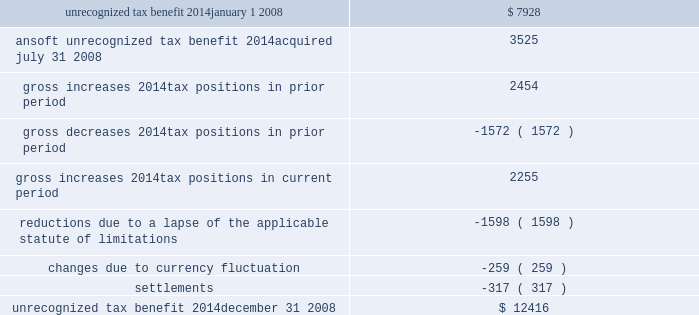The following is a reconciliation of the total amounts of unrecognized tax benefits for the year : ( in thousands ) .
Included in the balance of unrecognized tax benefits at december 31 , 2008 are $ 5.6 million of tax benefits that , if recognized , would affect the effective tax rate .
Also included in the balance of unrecognized tax benefits at december 31 , 2008 are $ 5.0 million of tax benefits that , if recognized , would result in a decrease to goodwill recorded in purchase business combinations , and $ 1.9 million of tax benefits that , if recognized , would result in adjustments to other tax accounts , primarily deferred taxes .
The company believes it is reasonably possible that uncertain tax positions of approximately $ 2.6 million as of december 31 , 2008 will be resolved within the next twelve months .
The company recognizes interest and penalties related to unrecognized tax benefits as income tax expense .
Related to the uncertain tax benefits noted above , the company recorded interest of $ 171000 during 2008 .
Penalties recorded during 2008 were insignificant .
In total , as of december 31 , 2008 , the company has recognized a liability for penalties of $ 498000 and interest of $ 1.8 million .
The company is subject to taxation in the u.s .
And various states and foreign jurisdictions .
The company 2019s 2005 through 2008 tax years are open to examination by the internal revenue service .
The 2005 and 2006 federal returns are currently under examination .
The company also has various foreign subsidiaries with tax filings under examination , as well as numerous foreign and state tax filings subject to examination for various years .
10 .
Pension and profit-sharing plans the company has 401 ( k ) /profit-sharing plans for all qualifying full-time domestic employees that permit participants to make contributions by salary reduction pursuant to section 401 ( k ) of the internal revenue code .
The company makes matching contributions on behalf of each eligible participant in an amount equal to 100% ( 100 % ) of the first 3% ( 3 % ) and an additional 25% ( 25 % ) of the next 5% ( 5 % ) , for a maximum total of 4.25% ( 4.25 % ) of the employee 2019s compensation .
The company may make a discretionary profit sharing contribution in the amount of 0% ( 0 % ) to 5% ( 5 % ) based on the participant 2019s eligible compensation , provided the employee is employed at the end of the year and has worked at least 1000 hours .
The qualifying domestic employees of the company 2019s ansoft subsidiary , acquired on july 31 , 2008 , also participate in a 401 ( k ) plan .
There is no matching employer contribution associated with this plan .
The company also maintains various defined contribution pension arrangements for its international employees .
Expenses related to the company 2019s retirement programs were $ 3.7 million in 2008 , $ 4.7 million in 2007 and $ 4.1 million in 2006 .
11 .
Non-compete and employment agreements employees of the company have signed agreements under which they have agreed not to disclose trade secrets or confidential information and , where legally permitted , that restrict engagement in or connection with any business that is competitive with the company anywhere in the world while employed by the company ( and .
What was the average expenses related to the company 2019s retirement programs from 2006 to 2008 in millions? 
Computations: (((3.7 + 4.7) + 4.1) / 3)
Answer: 4.16667. 